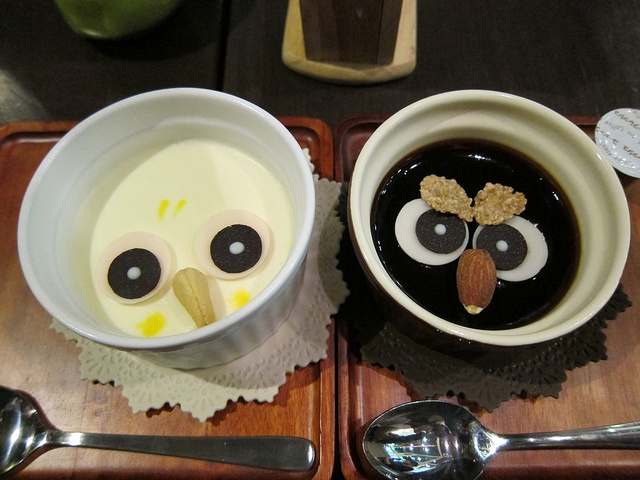Describe the objects in this image and their specific colors. I can see bowl in black, beige, darkgray, lightgray, and gray tones, bowl in black, darkgray, tan, and lightgray tones, dining table in black and gray tones, spoon in black, gray, darkgray, and white tones, and spoon in black, gray, and white tones in this image. 